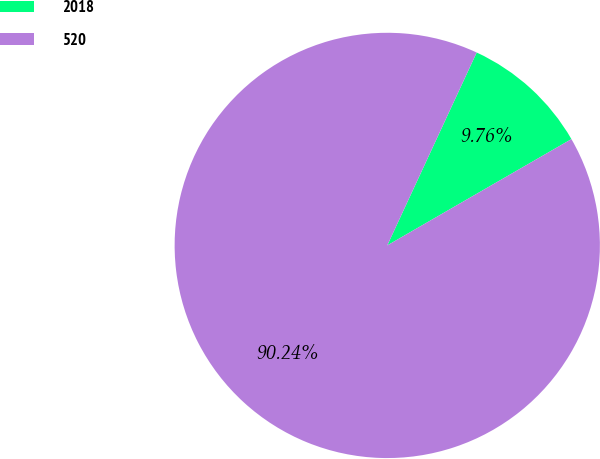Convert chart to OTSL. <chart><loc_0><loc_0><loc_500><loc_500><pie_chart><fcel>2018<fcel>520<nl><fcel>9.76%<fcel>90.24%<nl></chart> 